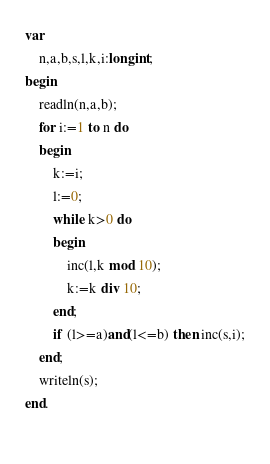<code> <loc_0><loc_0><loc_500><loc_500><_Pascal_>var
    n,a,b,s,l,k,i:longint;
begin
    readln(n,a,b);
    for i:=1 to n do
    begin
        k:=i;
        l:=0;
        while k>0 do
        begin
            inc(l,k mod 10);
            k:=k div 10;
        end;
        if (l>=a)and(l<=b) then inc(s,i);
    end;
    writeln(s);
end.
    </code> 